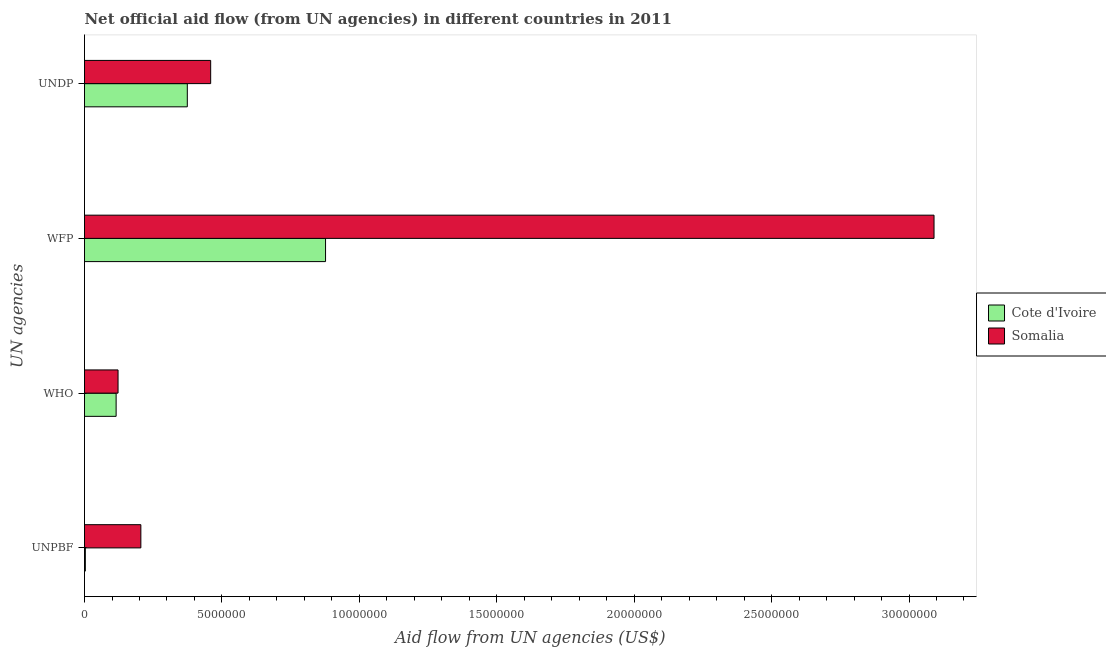How many groups of bars are there?
Keep it short and to the point. 4. How many bars are there on the 3rd tick from the top?
Ensure brevity in your answer.  2. How many bars are there on the 1st tick from the bottom?
Your response must be concise. 2. What is the label of the 4th group of bars from the top?
Offer a terse response. UNPBF. What is the amount of aid given by who in Cote d'Ivoire?
Keep it short and to the point. 1.15e+06. Across all countries, what is the maximum amount of aid given by wfp?
Provide a short and direct response. 3.09e+07. Across all countries, what is the minimum amount of aid given by unpbf?
Keep it short and to the point. 3.00e+04. In which country was the amount of aid given by who maximum?
Provide a short and direct response. Somalia. In which country was the amount of aid given by who minimum?
Ensure brevity in your answer.  Cote d'Ivoire. What is the total amount of aid given by undp in the graph?
Keep it short and to the point. 8.33e+06. What is the difference between the amount of aid given by unpbf in Somalia and that in Cote d'Ivoire?
Your answer should be compact. 2.02e+06. What is the difference between the amount of aid given by wfp in Cote d'Ivoire and the amount of aid given by unpbf in Somalia?
Provide a succinct answer. 6.72e+06. What is the average amount of aid given by who per country?
Your answer should be compact. 1.18e+06. What is the difference between the amount of aid given by unpbf and amount of aid given by who in Somalia?
Ensure brevity in your answer.  8.30e+05. In how many countries, is the amount of aid given by who greater than 15000000 US$?
Your answer should be very brief. 0. What is the ratio of the amount of aid given by unpbf in Somalia to that in Cote d'Ivoire?
Make the answer very short. 68.33. Is the amount of aid given by who in Somalia less than that in Cote d'Ivoire?
Ensure brevity in your answer.  No. Is the difference between the amount of aid given by unpbf in Somalia and Cote d'Ivoire greater than the difference between the amount of aid given by wfp in Somalia and Cote d'Ivoire?
Offer a very short reply. No. What is the difference between the highest and the second highest amount of aid given by unpbf?
Your answer should be compact. 2.02e+06. What is the difference between the highest and the lowest amount of aid given by undp?
Your answer should be very brief. 8.50e+05. In how many countries, is the amount of aid given by undp greater than the average amount of aid given by undp taken over all countries?
Offer a very short reply. 1. Is the sum of the amount of aid given by wfp in Cote d'Ivoire and Somalia greater than the maximum amount of aid given by who across all countries?
Keep it short and to the point. Yes. Is it the case that in every country, the sum of the amount of aid given by undp and amount of aid given by unpbf is greater than the sum of amount of aid given by wfp and amount of aid given by who?
Offer a very short reply. No. What does the 1st bar from the top in UNDP represents?
Your response must be concise. Somalia. What does the 2nd bar from the bottom in UNDP represents?
Your answer should be compact. Somalia. Is it the case that in every country, the sum of the amount of aid given by unpbf and amount of aid given by who is greater than the amount of aid given by wfp?
Keep it short and to the point. No. How many bars are there?
Make the answer very short. 8. Are all the bars in the graph horizontal?
Your answer should be compact. Yes. How many countries are there in the graph?
Make the answer very short. 2. What is the difference between two consecutive major ticks on the X-axis?
Your answer should be very brief. 5.00e+06. Does the graph contain grids?
Offer a terse response. No. How many legend labels are there?
Make the answer very short. 2. How are the legend labels stacked?
Keep it short and to the point. Vertical. What is the title of the graph?
Make the answer very short. Net official aid flow (from UN agencies) in different countries in 2011. Does "Jamaica" appear as one of the legend labels in the graph?
Offer a terse response. No. What is the label or title of the X-axis?
Your response must be concise. Aid flow from UN agencies (US$). What is the label or title of the Y-axis?
Offer a very short reply. UN agencies. What is the Aid flow from UN agencies (US$) of Somalia in UNPBF?
Provide a succinct answer. 2.05e+06. What is the Aid flow from UN agencies (US$) in Cote d'Ivoire in WHO?
Provide a short and direct response. 1.15e+06. What is the Aid flow from UN agencies (US$) in Somalia in WHO?
Provide a short and direct response. 1.22e+06. What is the Aid flow from UN agencies (US$) in Cote d'Ivoire in WFP?
Ensure brevity in your answer.  8.77e+06. What is the Aid flow from UN agencies (US$) of Somalia in WFP?
Provide a succinct answer. 3.09e+07. What is the Aid flow from UN agencies (US$) of Cote d'Ivoire in UNDP?
Offer a very short reply. 3.74e+06. What is the Aid flow from UN agencies (US$) in Somalia in UNDP?
Provide a short and direct response. 4.59e+06. Across all UN agencies, what is the maximum Aid flow from UN agencies (US$) in Cote d'Ivoire?
Provide a short and direct response. 8.77e+06. Across all UN agencies, what is the maximum Aid flow from UN agencies (US$) of Somalia?
Provide a short and direct response. 3.09e+07. Across all UN agencies, what is the minimum Aid flow from UN agencies (US$) in Somalia?
Ensure brevity in your answer.  1.22e+06. What is the total Aid flow from UN agencies (US$) of Cote d'Ivoire in the graph?
Your answer should be very brief. 1.37e+07. What is the total Aid flow from UN agencies (US$) in Somalia in the graph?
Provide a succinct answer. 3.88e+07. What is the difference between the Aid flow from UN agencies (US$) of Cote d'Ivoire in UNPBF and that in WHO?
Make the answer very short. -1.12e+06. What is the difference between the Aid flow from UN agencies (US$) in Somalia in UNPBF and that in WHO?
Your response must be concise. 8.30e+05. What is the difference between the Aid flow from UN agencies (US$) in Cote d'Ivoire in UNPBF and that in WFP?
Make the answer very short. -8.74e+06. What is the difference between the Aid flow from UN agencies (US$) of Somalia in UNPBF and that in WFP?
Your answer should be very brief. -2.89e+07. What is the difference between the Aid flow from UN agencies (US$) of Cote d'Ivoire in UNPBF and that in UNDP?
Provide a succinct answer. -3.71e+06. What is the difference between the Aid flow from UN agencies (US$) of Somalia in UNPBF and that in UNDP?
Your answer should be compact. -2.54e+06. What is the difference between the Aid flow from UN agencies (US$) in Cote d'Ivoire in WHO and that in WFP?
Ensure brevity in your answer.  -7.62e+06. What is the difference between the Aid flow from UN agencies (US$) of Somalia in WHO and that in WFP?
Give a very brief answer. -2.97e+07. What is the difference between the Aid flow from UN agencies (US$) of Cote d'Ivoire in WHO and that in UNDP?
Make the answer very short. -2.59e+06. What is the difference between the Aid flow from UN agencies (US$) in Somalia in WHO and that in UNDP?
Your answer should be compact. -3.37e+06. What is the difference between the Aid flow from UN agencies (US$) of Cote d'Ivoire in WFP and that in UNDP?
Your answer should be very brief. 5.03e+06. What is the difference between the Aid flow from UN agencies (US$) in Somalia in WFP and that in UNDP?
Provide a succinct answer. 2.63e+07. What is the difference between the Aid flow from UN agencies (US$) in Cote d'Ivoire in UNPBF and the Aid flow from UN agencies (US$) in Somalia in WHO?
Your answer should be compact. -1.19e+06. What is the difference between the Aid flow from UN agencies (US$) in Cote d'Ivoire in UNPBF and the Aid flow from UN agencies (US$) in Somalia in WFP?
Your answer should be compact. -3.09e+07. What is the difference between the Aid flow from UN agencies (US$) of Cote d'Ivoire in UNPBF and the Aid flow from UN agencies (US$) of Somalia in UNDP?
Provide a succinct answer. -4.56e+06. What is the difference between the Aid flow from UN agencies (US$) in Cote d'Ivoire in WHO and the Aid flow from UN agencies (US$) in Somalia in WFP?
Provide a short and direct response. -2.98e+07. What is the difference between the Aid flow from UN agencies (US$) in Cote d'Ivoire in WHO and the Aid flow from UN agencies (US$) in Somalia in UNDP?
Make the answer very short. -3.44e+06. What is the difference between the Aid flow from UN agencies (US$) in Cote d'Ivoire in WFP and the Aid flow from UN agencies (US$) in Somalia in UNDP?
Offer a very short reply. 4.18e+06. What is the average Aid flow from UN agencies (US$) in Cote d'Ivoire per UN agencies?
Your answer should be very brief. 3.42e+06. What is the average Aid flow from UN agencies (US$) of Somalia per UN agencies?
Make the answer very short. 9.69e+06. What is the difference between the Aid flow from UN agencies (US$) in Cote d'Ivoire and Aid flow from UN agencies (US$) in Somalia in UNPBF?
Provide a short and direct response. -2.02e+06. What is the difference between the Aid flow from UN agencies (US$) in Cote d'Ivoire and Aid flow from UN agencies (US$) in Somalia in WHO?
Keep it short and to the point. -7.00e+04. What is the difference between the Aid flow from UN agencies (US$) of Cote d'Ivoire and Aid flow from UN agencies (US$) of Somalia in WFP?
Provide a succinct answer. -2.21e+07. What is the difference between the Aid flow from UN agencies (US$) in Cote d'Ivoire and Aid flow from UN agencies (US$) in Somalia in UNDP?
Make the answer very short. -8.50e+05. What is the ratio of the Aid flow from UN agencies (US$) in Cote d'Ivoire in UNPBF to that in WHO?
Your response must be concise. 0.03. What is the ratio of the Aid flow from UN agencies (US$) of Somalia in UNPBF to that in WHO?
Ensure brevity in your answer.  1.68. What is the ratio of the Aid flow from UN agencies (US$) in Cote d'Ivoire in UNPBF to that in WFP?
Provide a short and direct response. 0. What is the ratio of the Aid flow from UN agencies (US$) in Somalia in UNPBF to that in WFP?
Provide a short and direct response. 0.07. What is the ratio of the Aid flow from UN agencies (US$) of Cote d'Ivoire in UNPBF to that in UNDP?
Ensure brevity in your answer.  0.01. What is the ratio of the Aid flow from UN agencies (US$) in Somalia in UNPBF to that in UNDP?
Your response must be concise. 0.45. What is the ratio of the Aid flow from UN agencies (US$) in Cote d'Ivoire in WHO to that in WFP?
Your response must be concise. 0.13. What is the ratio of the Aid flow from UN agencies (US$) in Somalia in WHO to that in WFP?
Your answer should be very brief. 0.04. What is the ratio of the Aid flow from UN agencies (US$) in Cote d'Ivoire in WHO to that in UNDP?
Make the answer very short. 0.31. What is the ratio of the Aid flow from UN agencies (US$) of Somalia in WHO to that in UNDP?
Make the answer very short. 0.27. What is the ratio of the Aid flow from UN agencies (US$) of Cote d'Ivoire in WFP to that in UNDP?
Your response must be concise. 2.34. What is the ratio of the Aid flow from UN agencies (US$) of Somalia in WFP to that in UNDP?
Ensure brevity in your answer.  6.73. What is the difference between the highest and the second highest Aid flow from UN agencies (US$) in Cote d'Ivoire?
Provide a short and direct response. 5.03e+06. What is the difference between the highest and the second highest Aid flow from UN agencies (US$) in Somalia?
Give a very brief answer. 2.63e+07. What is the difference between the highest and the lowest Aid flow from UN agencies (US$) of Cote d'Ivoire?
Make the answer very short. 8.74e+06. What is the difference between the highest and the lowest Aid flow from UN agencies (US$) in Somalia?
Your response must be concise. 2.97e+07. 